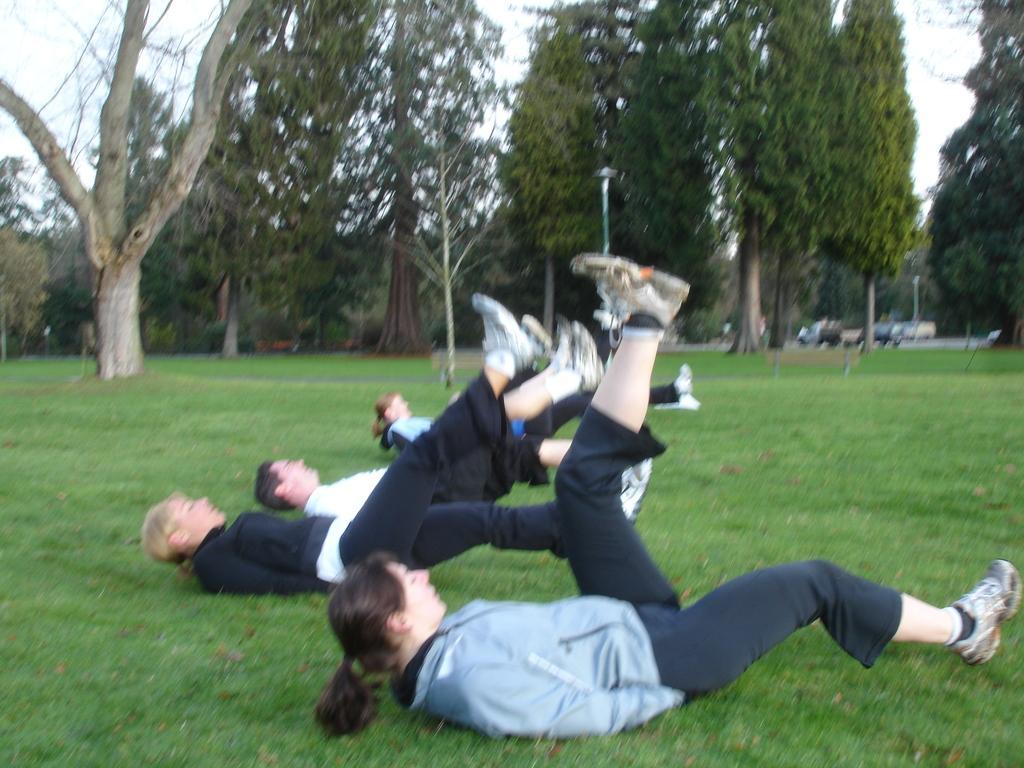How would you summarize this image in a sentence or two? There are people lying on a grassy land as we can see at the bottom of this image. There are trees in the background, and there is a sky at the top of this image. 